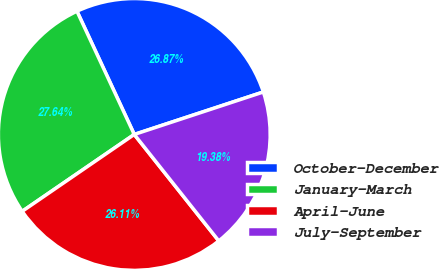Convert chart to OTSL. <chart><loc_0><loc_0><loc_500><loc_500><pie_chart><fcel>October-December<fcel>January-March<fcel>April-June<fcel>July-September<nl><fcel>26.87%<fcel>27.64%<fcel>26.11%<fcel>19.38%<nl></chart> 